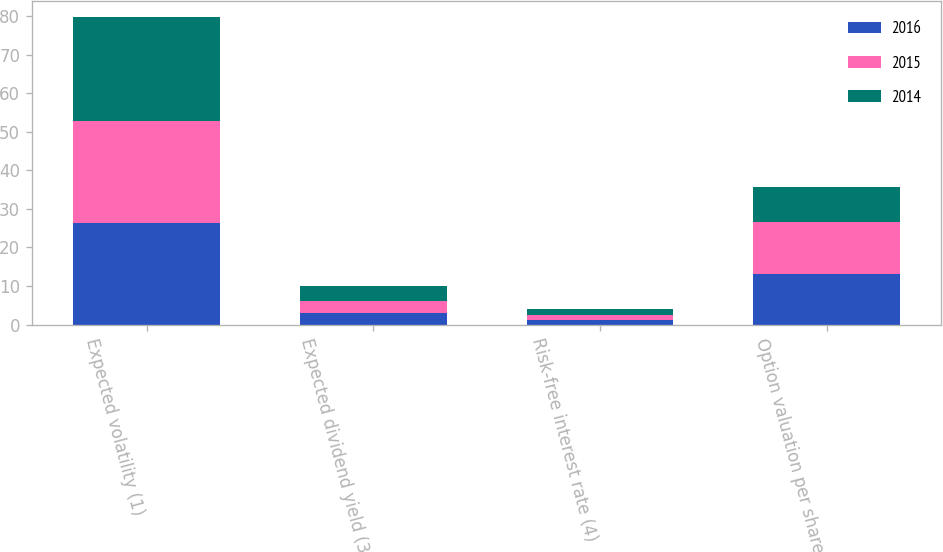Convert chart. <chart><loc_0><loc_0><loc_500><loc_500><stacked_bar_chart><ecel><fcel>Expected volatility (1)<fcel>Expected dividend yield (3)<fcel>Risk-free interest rate (4)<fcel>Option valuation per share<nl><fcel>2016<fcel>26.3<fcel>3.04<fcel>1.27<fcel>13.02<nl><fcel>2015<fcel>26.6<fcel>3.13<fcel>1.29<fcel>13.68<nl><fcel>2014<fcel>27<fcel>3.78<fcel>1.5<fcel>9.12<nl></chart> 